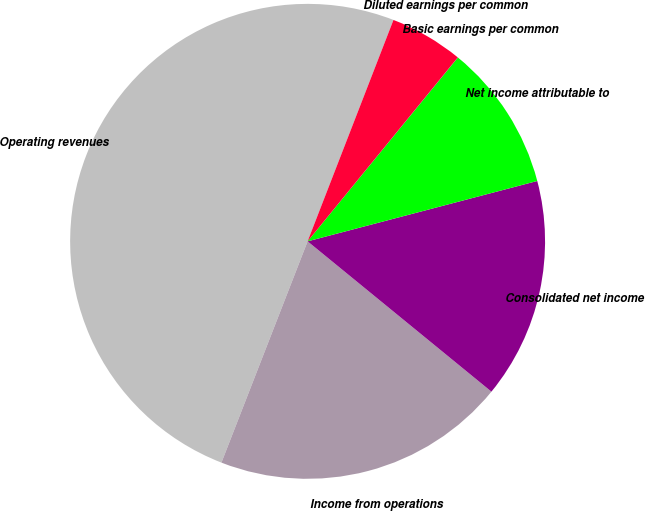Convert chart. <chart><loc_0><loc_0><loc_500><loc_500><pie_chart><fcel>Operating revenues<fcel>Income from operations<fcel>Consolidated net income<fcel>Net income attributable to<fcel>Basic earnings per common<fcel>Diluted earnings per common<nl><fcel>49.98%<fcel>20.0%<fcel>15.0%<fcel>10.0%<fcel>0.01%<fcel>5.01%<nl></chart> 